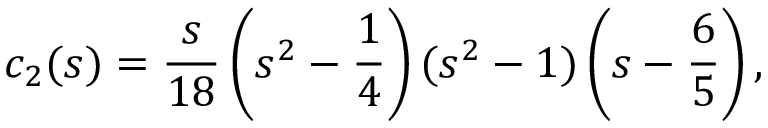<formula> <loc_0><loc_0><loc_500><loc_500>c _ { 2 } ( s ) = \frac { s } { 1 8 } \left ( s ^ { 2 } - \frac { 1 } { 4 } \right ) ( s ^ { 2 } - 1 ) \left ( s - \frac { 6 } { 5 } \right ) { , }</formula> 